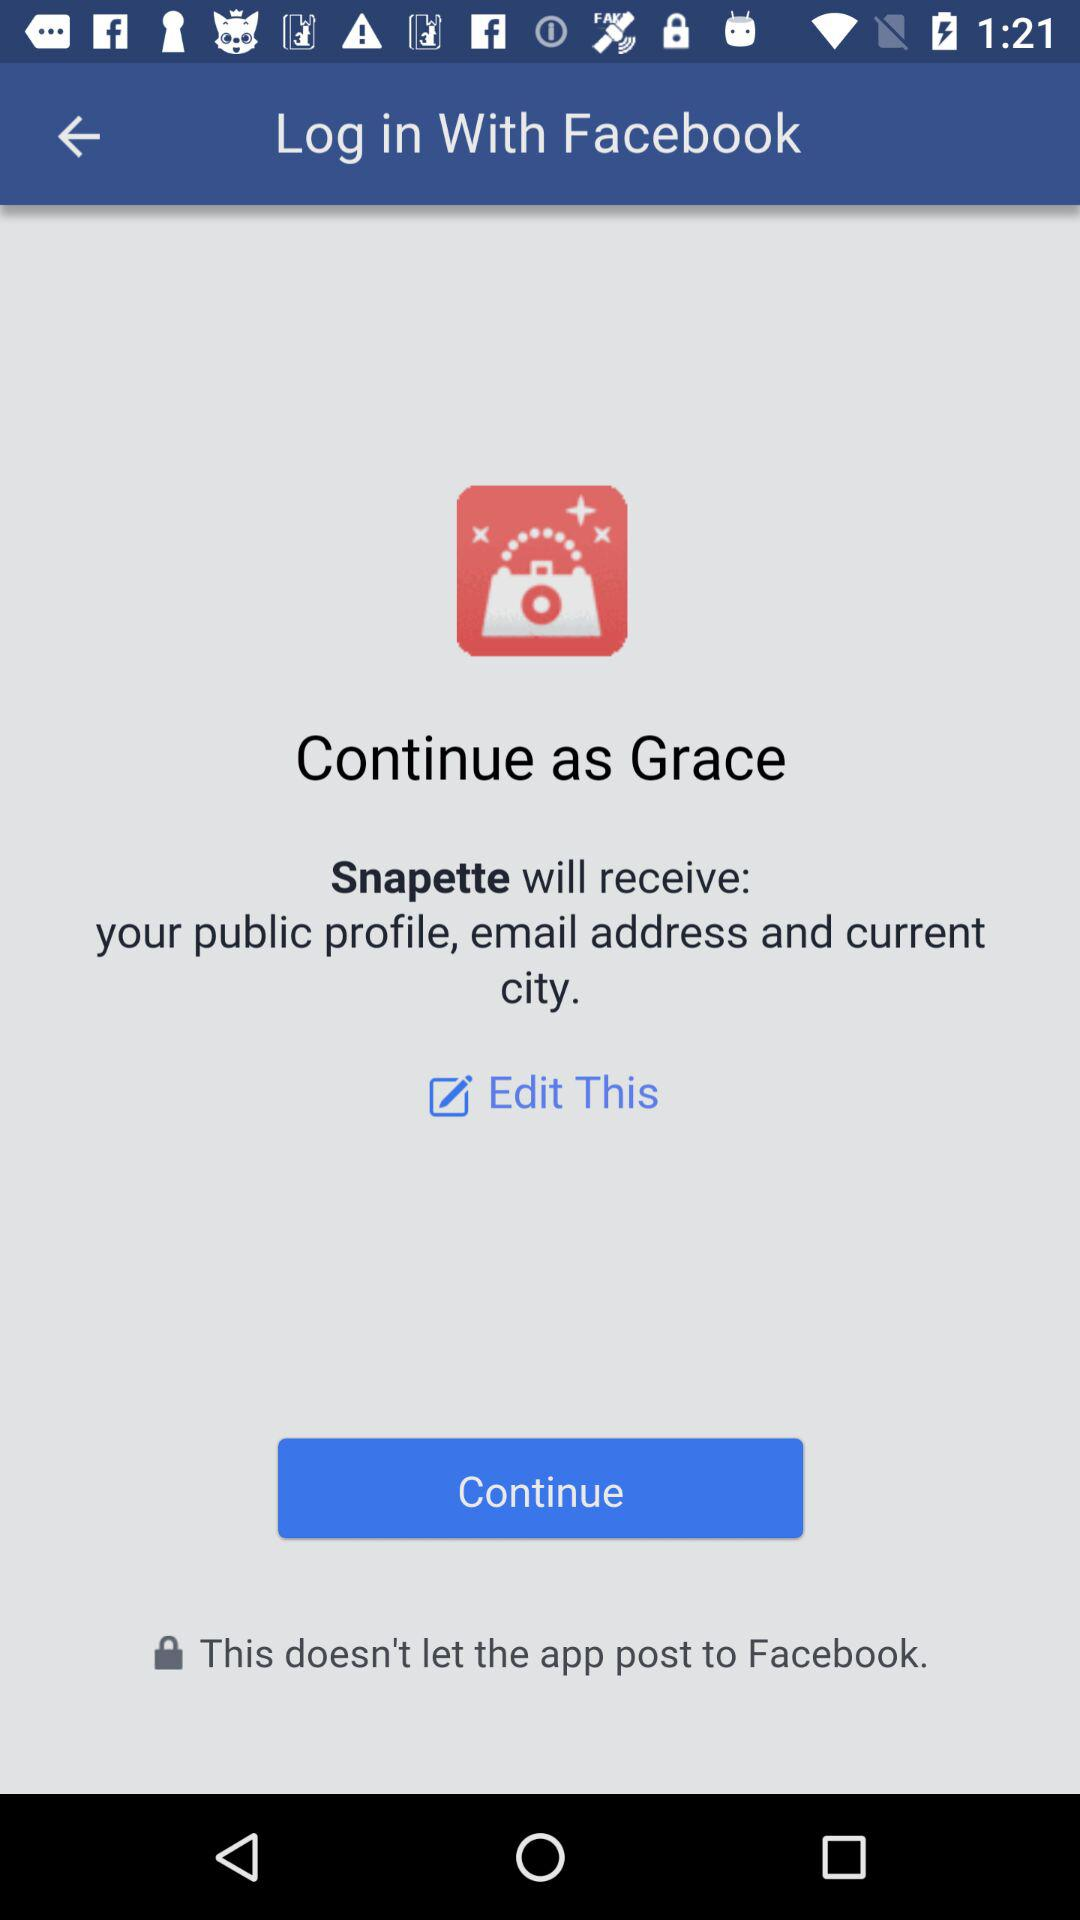What application is asking for permission? The application is "Snapette". 